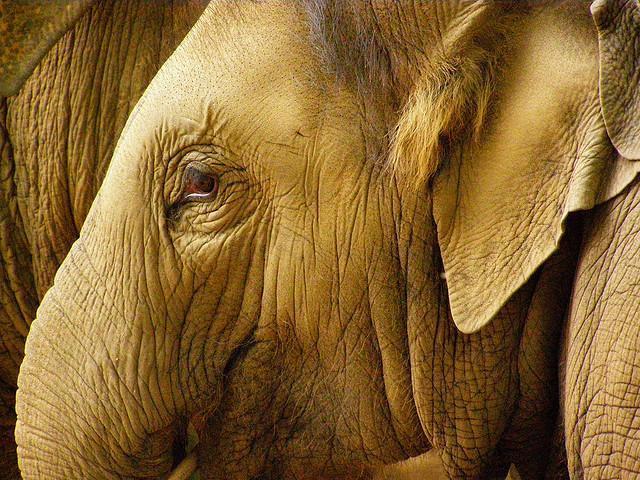How many elephants are there?
Give a very brief answer. 2. How many cups are empty on the table?
Give a very brief answer. 0. 